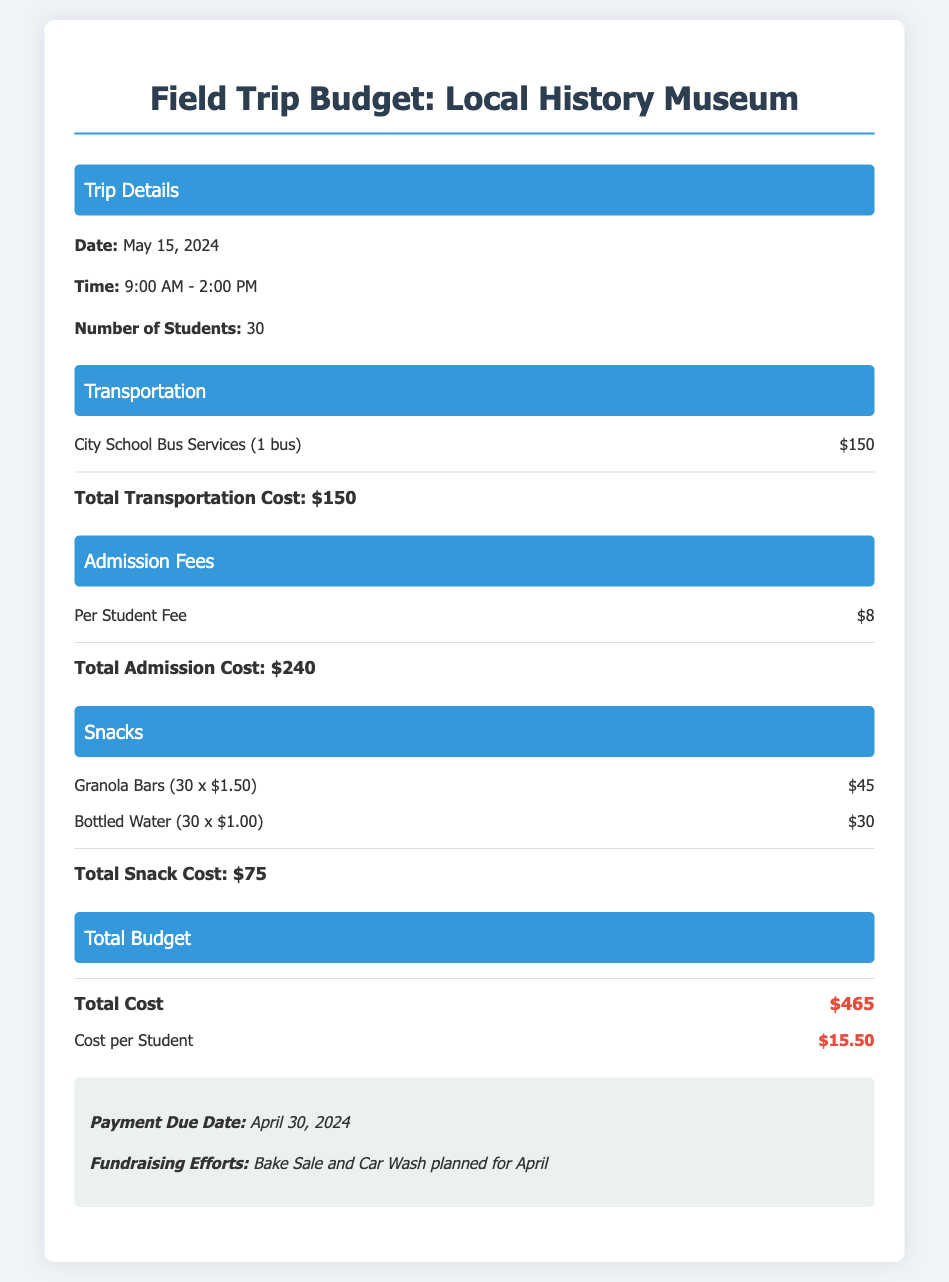What is the date of the field trip? The date is listed in the Trip Details section of the document.
Answer: May 15, 2024 What is the total transportation cost? The total cost for transportation is provided in the Transportation section.
Answer: $150 How many students are attending the trip? The number of students is noted in the Trip Details section.
Answer: 30 What is the total admission cost? The total admission cost is calculated based on the per student fee in the Admission Fees section.
Answer: $240 What is the cost per student? The cost per student is summarized in the Total Budget section by dividing the total cost by the number of students.
Answer: $15.50 What snacks are included in the budget? The document lists specific snack items in the Snacks section, which can be identified by their names and quantities.
Answer: Granola Bars and Bottled Water What fundraising efforts are mentioned? The document includes details about planned fundraising activities in the Notes section.
Answer: Bake Sale and Car Wash What time does the trip start? The start time is mentioned in the Trip Details section of the document.
Answer: 9:00 AM What is the total budget for the field trip? The total budget is stated clearly in the Total Budget section.
Answer: $465 